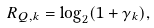<formula> <loc_0><loc_0><loc_500><loc_500>R _ { Q , k } = \log _ { 2 } ( 1 + \gamma _ { k } ) ,</formula> 